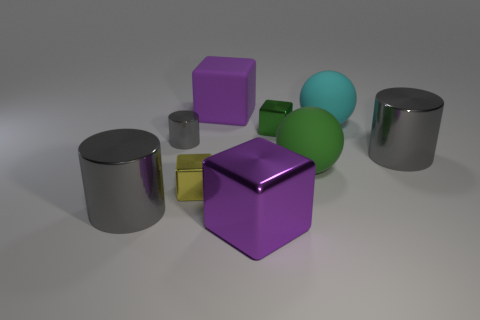How many gray cylinders must be subtracted to get 1 gray cylinders? 2 Subtract all red cubes. Subtract all yellow balls. How many cubes are left? 4 Add 1 tiny blue things. How many objects exist? 10 Subtract all blocks. How many objects are left? 5 Subtract 0 red blocks. How many objects are left? 9 Subtract all small red rubber blocks. Subtract all blocks. How many objects are left? 5 Add 4 balls. How many balls are left? 6 Add 1 small yellow matte cylinders. How many small yellow matte cylinders exist? 1 